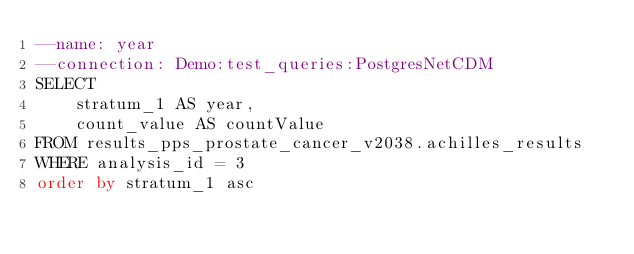<code> <loc_0><loc_0><loc_500><loc_500><_SQL_>--name: year
--connection: Demo:test_queries:PostgresNetCDM
SELECT 
    stratum_1 AS year, 
    count_value AS countValue
FROM results_pps_prostate_cancer_v2038.achilles_results 
WHERE analysis_id = 3
order by stratum_1 asc</code> 